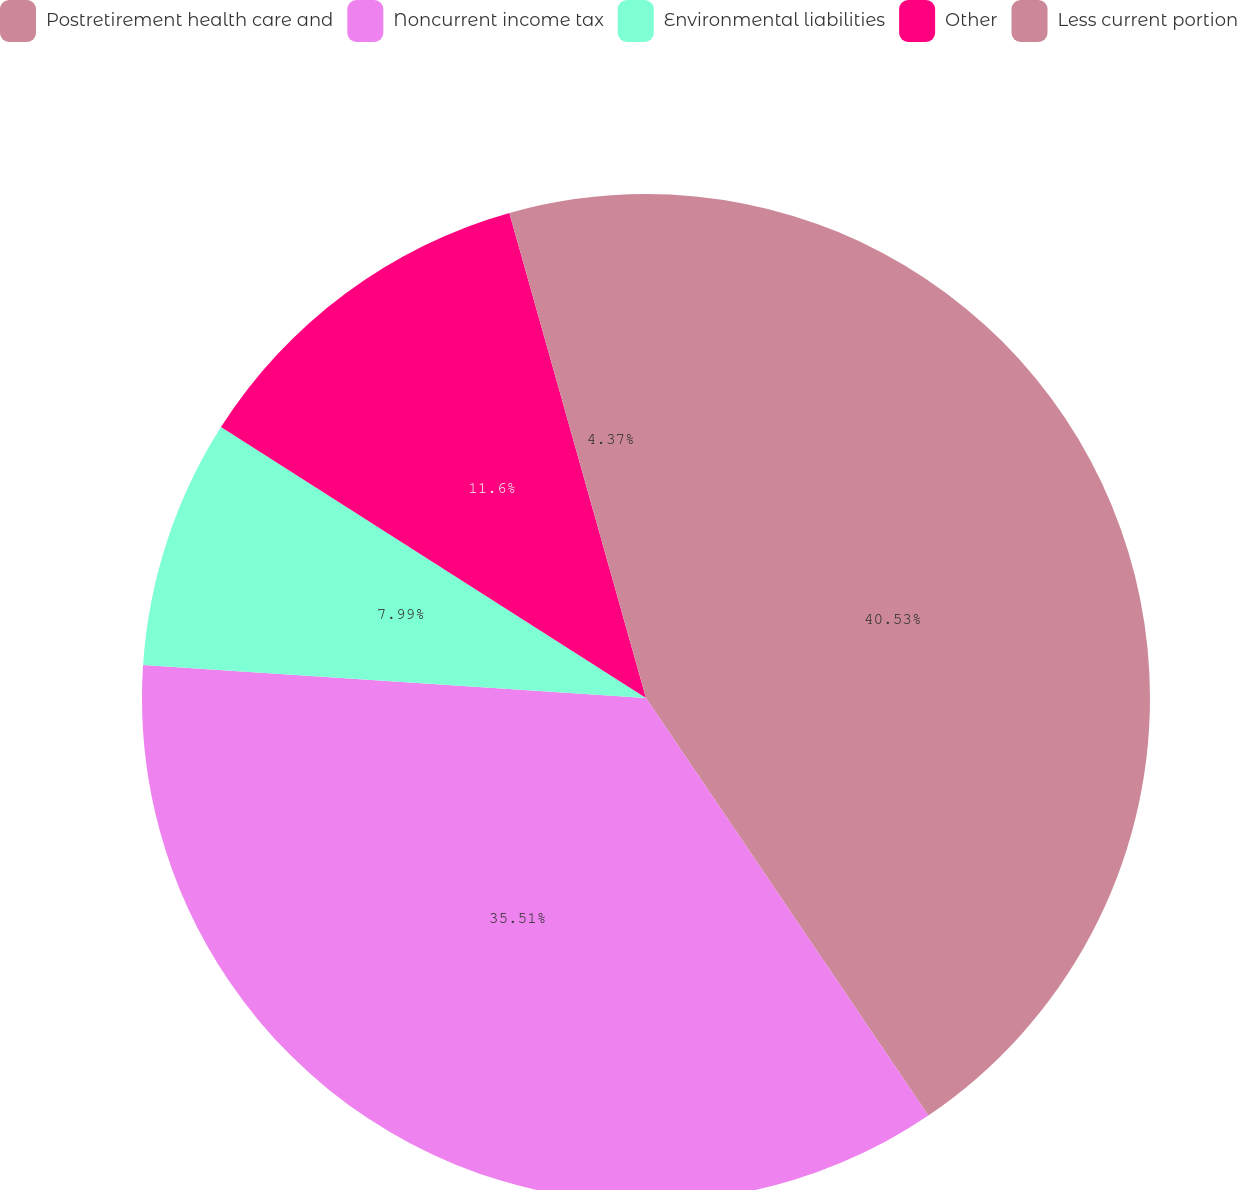<chart> <loc_0><loc_0><loc_500><loc_500><pie_chart><fcel>Postretirement health care and<fcel>Noncurrent income tax<fcel>Environmental liabilities<fcel>Other<fcel>Less current portion<nl><fcel>40.54%<fcel>35.51%<fcel>7.99%<fcel>11.6%<fcel>4.37%<nl></chart> 